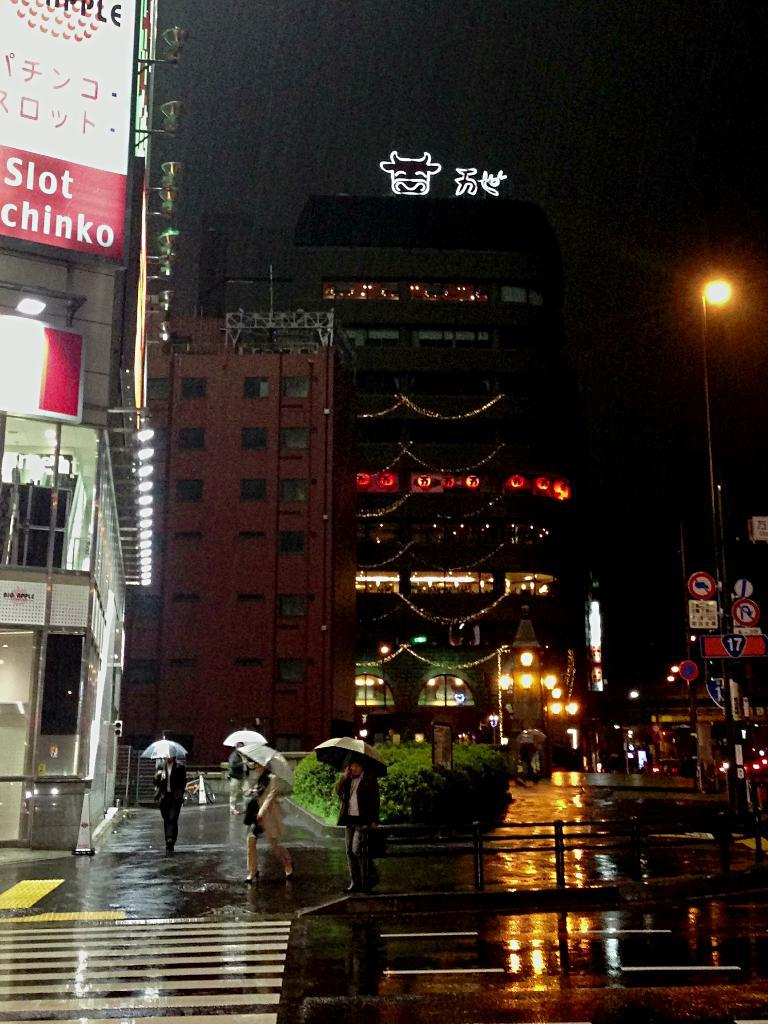What are the people at the bottom of the image doing? The people at the bottom of the image are walking. What are the people holding while walking? The people are holding umbrellas. What can be seen in the image besides the people walking? There are plants, buildings, poles, and sign boards visible in the image. Where is the soap located in the image? There is no soap present in the image. What type of toy can be seen in the hands of the people walking? There are no toys visible in the image; the people are holding umbrellas. 